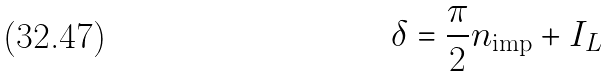<formula> <loc_0><loc_0><loc_500><loc_500>\delta = \frac { \pi } { 2 } n _ { \text {imp} } + I _ { L }</formula> 